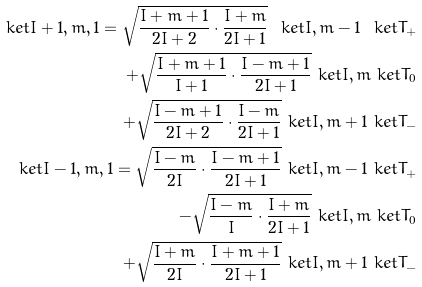<formula> <loc_0><loc_0><loc_500><loc_500>\ k e t { I + 1 , m , 1 } = \sqrt { \frac { I + m + 1 } { 2 I + 2 } \cdot \frac { I + m } { 2 I + 1 } } \ k e t { I , m - 1 } \ k e t { T _ { + } } \\ + \sqrt { \frac { I + m + 1 } { I + 1 } \cdot \frac { I - m + 1 } { 2 I + 1 } } \ k e t { I , m } \ k e t { T _ { 0 } } \\ + \sqrt { \frac { I - m + 1 } { 2 I + 2 } \cdot \frac { I - m } { 2 I + 1 } } \ k e t { I , m + 1 } \ k e t { T _ { - } } \\ \ k e t { I - 1 , m , 1 } = \sqrt { \frac { I - m } { 2 I } \cdot \frac { I - m + 1 } { 2 I + 1 } } \ k e t { I , m - 1 } \ k e t { T _ { + } } \\ - \sqrt { \frac { I - m } { I } \cdot \frac { I + m } { 2 I + 1 } } \ k e t { I , m } \ k e t { T _ { 0 } } \\ + \sqrt { \frac { I + m } { 2 I } \cdot \frac { I + m + 1 } { 2 I + 1 } } \ k e t { I , m + 1 } \ k e t { T _ { - } }</formula> 